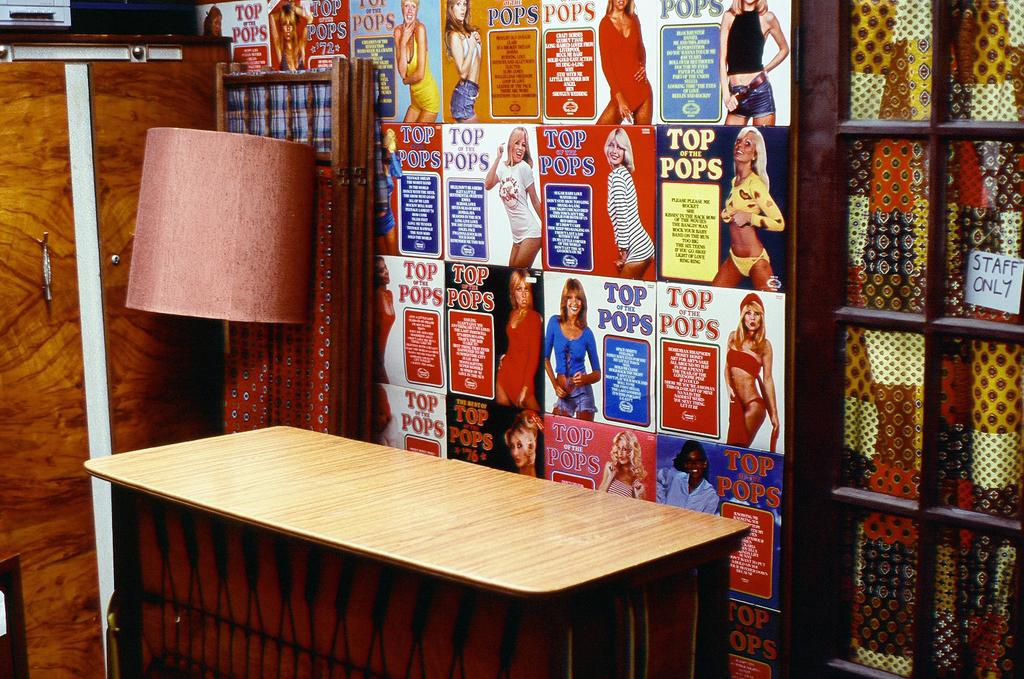<image>
Render a clear and concise summary of the photo. Top of the Pops record albums or posters with buxom women are displayed behind a counter. 